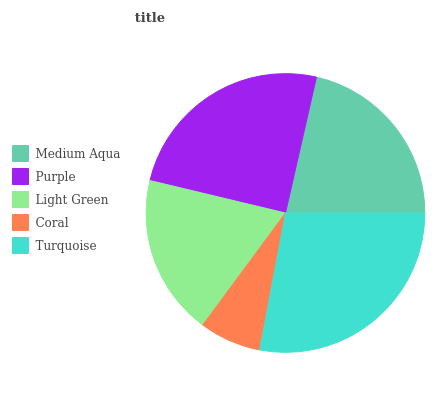Is Coral the minimum?
Answer yes or no. Yes. Is Turquoise the maximum?
Answer yes or no. Yes. Is Purple the minimum?
Answer yes or no. No. Is Purple the maximum?
Answer yes or no. No. Is Purple greater than Medium Aqua?
Answer yes or no. Yes. Is Medium Aqua less than Purple?
Answer yes or no. Yes. Is Medium Aqua greater than Purple?
Answer yes or no. No. Is Purple less than Medium Aqua?
Answer yes or no. No. Is Medium Aqua the high median?
Answer yes or no. Yes. Is Medium Aqua the low median?
Answer yes or no. Yes. Is Coral the high median?
Answer yes or no. No. Is Purple the low median?
Answer yes or no. No. 